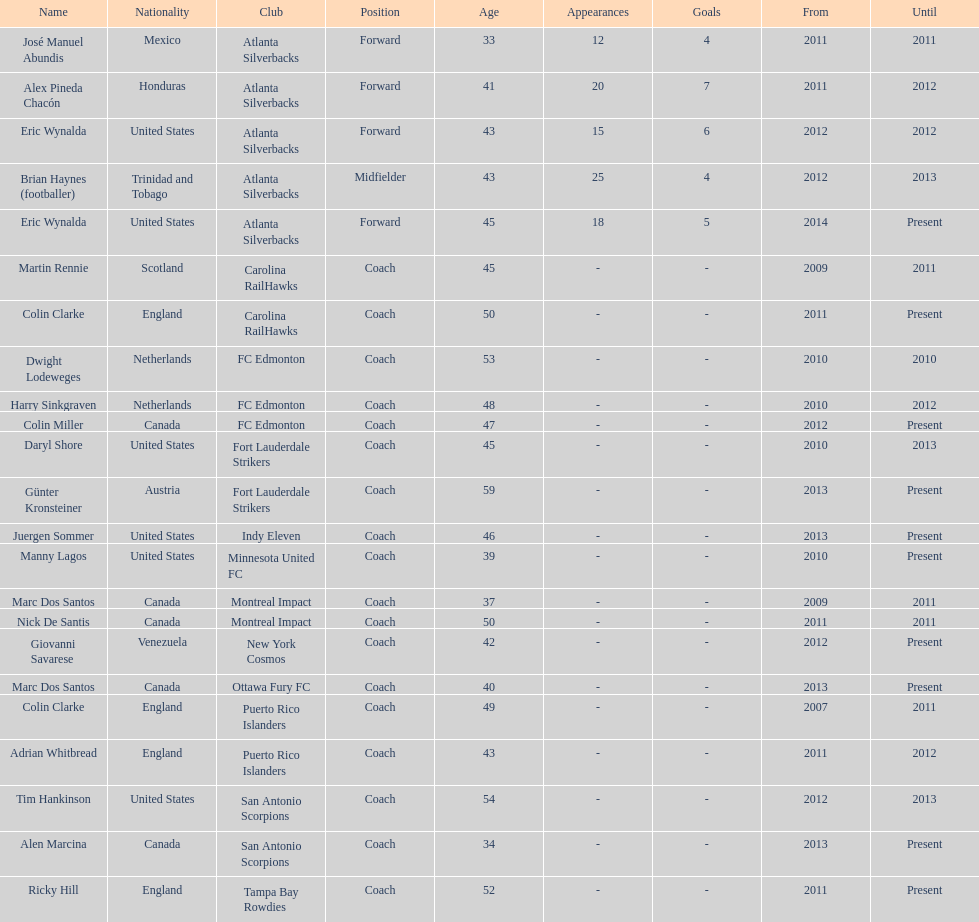Who coached the silverbacks longer, abundis or chacon? Chacon. I'm looking to parse the entire table for insights. Could you assist me with that? {'header': ['Name', 'Nationality', 'Club', 'Position', 'Age', 'Appearances', 'Goals', 'From', 'Until'], 'rows': [['José Manuel Abundis', 'Mexico', 'Atlanta Silverbacks', 'Forward', '33', '12', '4', '2011', '2011'], ['Alex Pineda Chacón', 'Honduras', 'Atlanta Silverbacks', 'Forward', '41', '20', '7', '2011', '2012'], ['Eric Wynalda', 'United States', 'Atlanta Silverbacks', 'Forward', '43', '15', '6', '2012', '2012'], ['Brian Haynes (footballer)', 'Trinidad and Tobago', 'Atlanta Silverbacks', 'Midfielder', '43', '25', '4', '2012', '2013'], ['Eric Wynalda', 'United States', 'Atlanta Silverbacks', 'Forward', '45', '18', '5', '2014', 'Present'], ['Martin Rennie', 'Scotland', 'Carolina RailHawks', 'Coach', '45', '-', '-', '2009', '2011'], ['Colin Clarke', 'England', 'Carolina RailHawks', 'Coach', '50', '-', '-', '2011', 'Present'], ['Dwight Lodeweges', 'Netherlands', 'FC Edmonton', 'Coach', '53', '-', '-', '2010', '2010'], ['Harry Sinkgraven', 'Netherlands', 'FC Edmonton', 'Coach', '48', '-', '-', '2010', '2012'], ['Colin Miller', 'Canada', 'FC Edmonton', 'Coach', '47', '-', '-', '2012', 'Present'], ['Daryl Shore', 'United States', 'Fort Lauderdale Strikers', 'Coach', '45', '-', '-', '2010', '2013'], ['Günter Kronsteiner', 'Austria', 'Fort Lauderdale Strikers', 'Coach', '59', '-', '-', '2013', 'Present'], ['Juergen Sommer', 'United States', 'Indy Eleven', 'Coach', '46', '-', '-', '2013', 'Present'], ['Manny Lagos', 'United States', 'Minnesota United FC', 'Coach', '39', '-', '-', '2010', 'Present'], ['Marc Dos Santos', 'Canada', 'Montreal Impact', 'Coach', '37', '-', '-', '2009', '2011'], ['Nick De Santis', 'Canada', 'Montreal Impact', 'Coach', '50', '-', '-', '2011', '2011'], ['Giovanni Savarese', 'Venezuela', 'New York Cosmos', 'Coach', '42', '-', '-', '2012', 'Present'], ['Marc Dos Santos', 'Canada', 'Ottawa Fury FC', 'Coach', '40', '-', '-', '2013', 'Present'], ['Colin Clarke', 'England', 'Puerto Rico Islanders', 'Coach', '49', '-', '-', '2007', '2011'], ['Adrian Whitbread', 'England', 'Puerto Rico Islanders', 'Coach', '43', '-', '-', '2011', '2012'], ['Tim Hankinson', 'United States', 'San Antonio Scorpions', 'Coach', '54', '-', '-', '2012', '2013'], ['Alen Marcina', 'Canada', 'San Antonio Scorpions', 'Coach', '34', '-', '-', '2013', 'Present'], ['Ricky Hill', 'England', 'Tampa Bay Rowdies', 'Coach', '52', '-', '-', '2011', 'Present']]} 